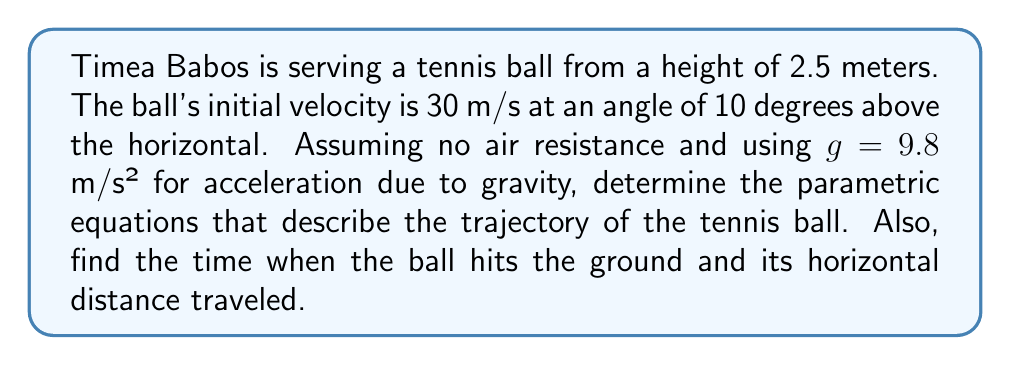Could you help me with this problem? Let's approach this step-by-step:

1) First, we need to set up our coordinate system. Let's use:
   - x-axis: horizontal distance
   - y-axis: vertical distance
   - Origin (0,0): point on the ground directly below the serve point

2) We can use the following parametric equations to describe the ball's motion:

   $$x(t) = x_0 + v_0 \cos(\theta) t$$
   $$y(t) = y_0 + v_0 \sin(\theta) t - \frac{1}{2}gt^2$$

   Where:
   - $x_0$ and $y_0$ are initial positions
   - $v_0$ is initial velocity
   - $\theta$ is the angle above horizontal
   - $t$ is time
   - $g$ is acceleration due to gravity

3) Given information:
   - $x_0 = 0$ m (starting at origin)
   - $y_0 = 2.5$ m (initial height)
   - $v_0 = 30$ m/s
   - $\theta = 10°$
   - $g = 9.8$ m/s²

4) Let's substitute these values:

   $$x(t) = 0 + 30 \cos(10°) t = 29.54t$$
   $$y(t) = 2.5 + 30 \sin(10°) t - \frac{1}{2}(9.8)t^2 = 2.5 + 5.21t - 4.9t^2$$

5) To find when the ball hits the ground, we need to solve $y(t) = 0$:

   $$0 = 2.5 + 5.21t - 4.9t^2$$

   This is a quadratic equation. Using the quadratic formula:

   $$t = \frac{-5.21 \pm \sqrt{5.21^2 + 4(4.9)(2.5)}}{2(-4.9)}$$

   $$t \approx 1.37 \text{ seconds}$$ (positive root, as negative time doesn't make sense here)

6) To find the horizontal distance traveled, we substitute this time into $x(t)$:

   $$x(1.37) = 29.54(1.37) \approx 40.47 \text{ meters}$$
Answer: The parametric equations describing the trajectory are:

$$x(t) = 29.54t$$
$$y(t) = 2.5 + 5.21t - 4.9t^2$$

The ball hits the ground after approximately 1.37 seconds and travels a horizontal distance of about 40.47 meters. 